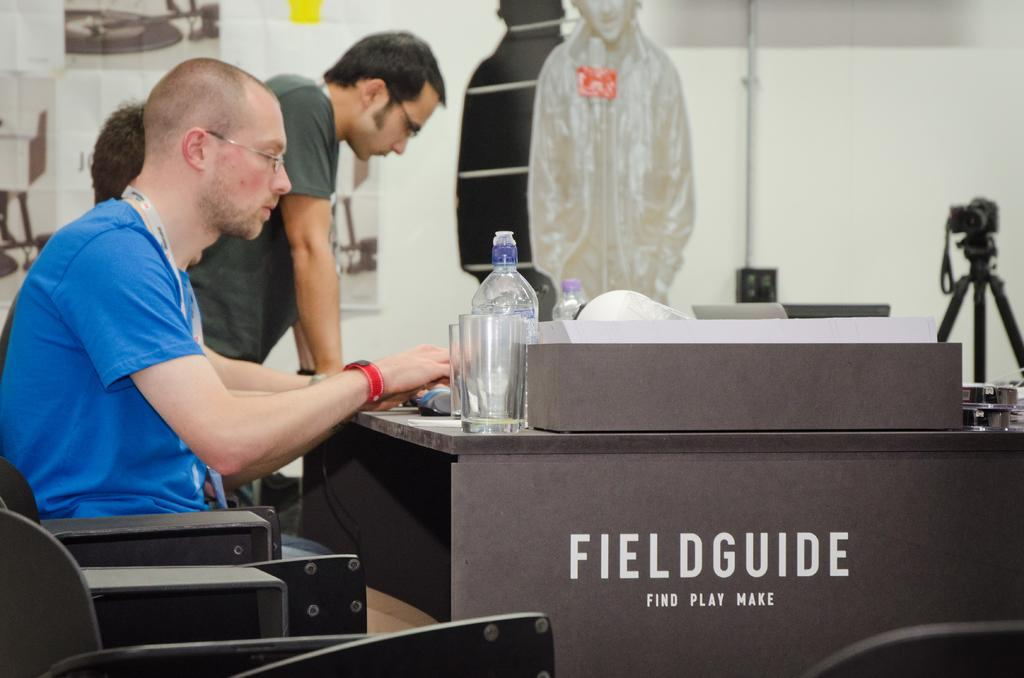How many people are in the image? There are three people in the image. What are the positions of the people in the image? Two of the people are sitting, and one person is standing. What objects can be seen on the table in the image? There is a glass and a bottle on the table. Can you describe any other items visible in the image? There is a camera visible in the background. What type of doctor is attending to the person standing in the image? There is no doctor present in the image, and no one is being attended to. 